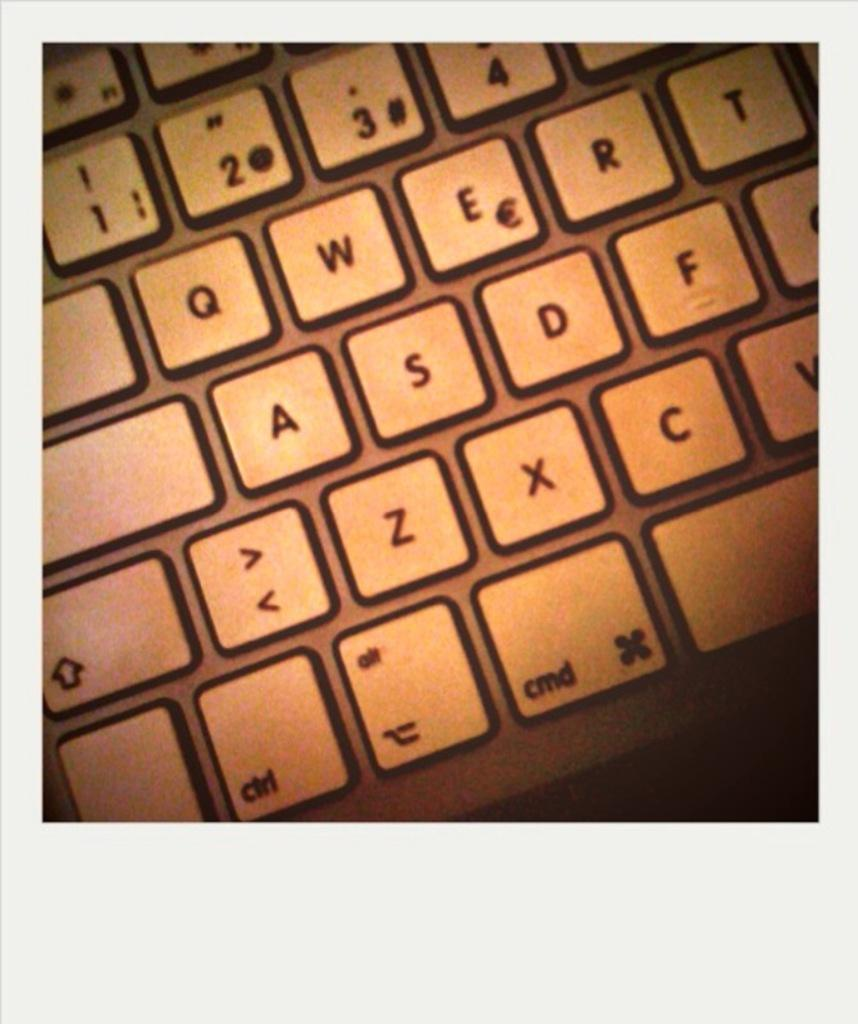Provide a one-sentence caption for the provided image. A keyboard that has the numbers 1,2,3, and 4 at the top of it. 